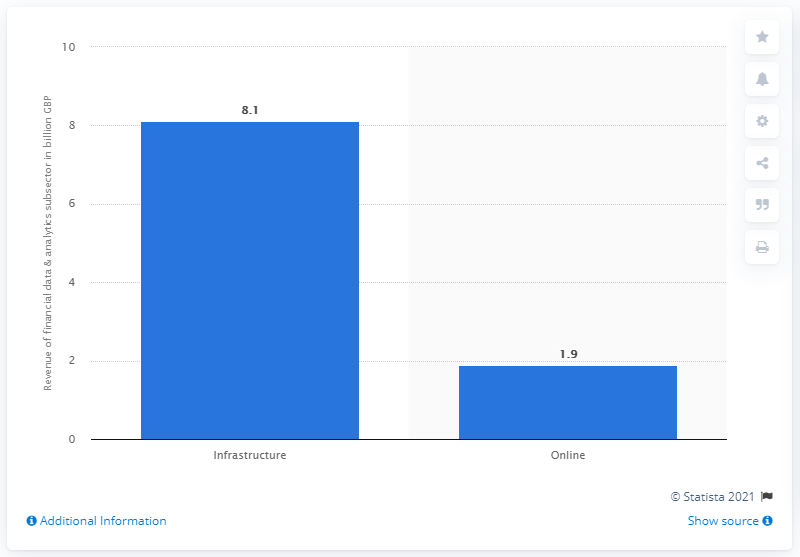Outline some significant characteristics in this image. The annual revenue of the payments subsector was $8.1 billion in 2020. 